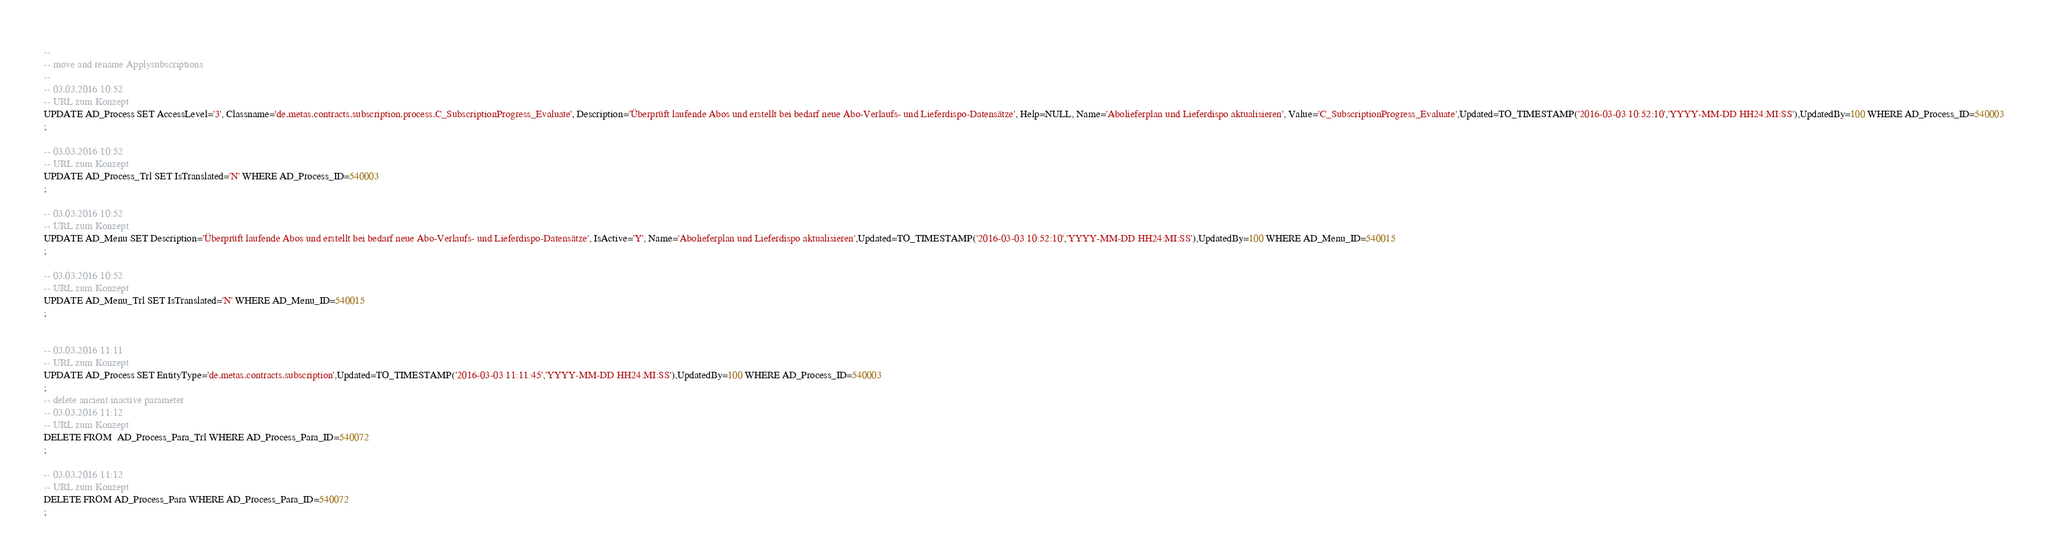Convert code to text. <code><loc_0><loc_0><loc_500><loc_500><_SQL_>
--
-- move and rename Applysubscriptions
--
-- 03.03.2016 10:52
-- URL zum Konzept
UPDATE AD_Process SET AccessLevel='3', Classname='de.metas.contracts.subscription.process.C_SubscriptionProgress_Evaluate', Description='Überprüft laufende Abos und erstellt bei bedarf neue Abo-Verlaufs- und Lieferdispo-Datensätze', Help=NULL, Name='Abolieferplan und Lieferdispo aktualisieren', Value='C_SubscriptionProgress_Evaluate',Updated=TO_TIMESTAMP('2016-03-03 10:52:10','YYYY-MM-DD HH24:MI:SS'),UpdatedBy=100 WHERE AD_Process_ID=540003
;

-- 03.03.2016 10:52
-- URL zum Konzept
UPDATE AD_Process_Trl SET IsTranslated='N' WHERE AD_Process_ID=540003
;

-- 03.03.2016 10:52
-- URL zum Konzept
UPDATE AD_Menu SET Description='Überprüft laufende Abos und erstellt bei bedarf neue Abo-Verlaufs- und Lieferdispo-Datensätze', IsActive='Y', Name='Abolieferplan und Lieferdispo aktualisieren',Updated=TO_TIMESTAMP('2016-03-03 10:52:10','YYYY-MM-DD HH24:MI:SS'),UpdatedBy=100 WHERE AD_Menu_ID=540015
;

-- 03.03.2016 10:52
-- URL zum Konzept
UPDATE AD_Menu_Trl SET IsTranslated='N' WHERE AD_Menu_ID=540015
;


-- 03.03.2016 11:11
-- URL zum Konzept
UPDATE AD_Process SET EntityType='de.metas.contracts.subscription',Updated=TO_TIMESTAMP('2016-03-03 11:11:45','YYYY-MM-DD HH24:MI:SS'),UpdatedBy=100 WHERE AD_Process_ID=540003
;
-- delete ancient inactive parameter
-- 03.03.2016 11:12
-- URL zum Konzept
DELETE FROM  AD_Process_Para_Trl WHERE AD_Process_Para_ID=540072
;

-- 03.03.2016 11:12
-- URL zum Konzept
DELETE FROM AD_Process_Para WHERE AD_Process_Para_ID=540072
;
</code> 